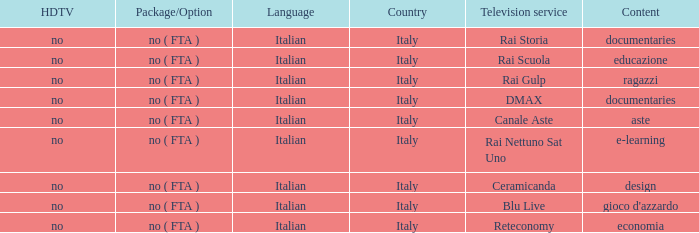What is the Country with Reteconomy as the Television service? Italy. 